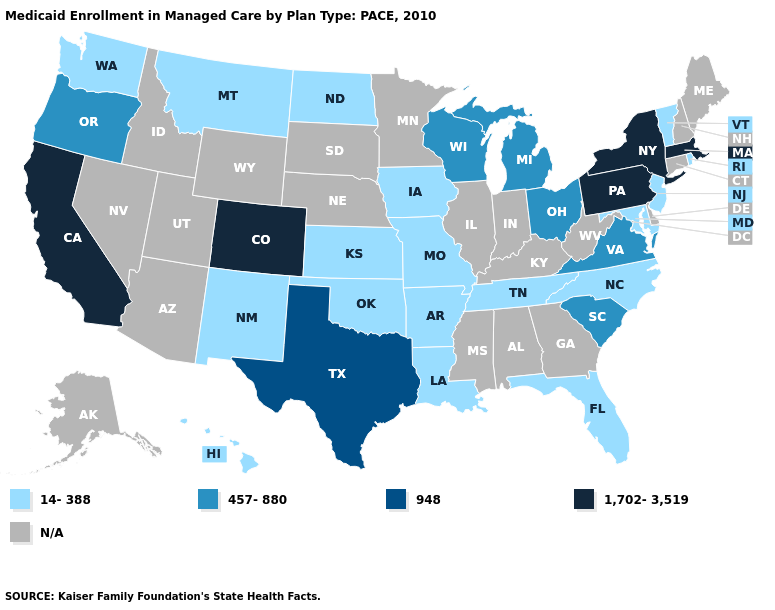Among the states that border Wyoming , which have the highest value?
Quick response, please. Colorado. Name the states that have a value in the range 1,702-3,519?
Short answer required. California, Colorado, Massachusetts, New York, Pennsylvania. Name the states that have a value in the range 14-388?
Keep it brief. Arkansas, Florida, Hawaii, Iowa, Kansas, Louisiana, Maryland, Missouri, Montana, New Jersey, New Mexico, North Carolina, North Dakota, Oklahoma, Rhode Island, Tennessee, Vermont, Washington. Is the legend a continuous bar?
Write a very short answer. No. Which states have the highest value in the USA?
Quick response, please. California, Colorado, Massachusetts, New York, Pennsylvania. Is the legend a continuous bar?
Keep it brief. No. Does Oregon have the highest value in the West?
Give a very brief answer. No. What is the lowest value in the West?
Give a very brief answer. 14-388. Does the first symbol in the legend represent the smallest category?
Write a very short answer. Yes. What is the highest value in the Northeast ?
Keep it brief. 1,702-3,519. Does Kansas have the lowest value in the USA?
Quick response, please. Yes. Name the states that have a value in the range 948?
Give a very brief answer. Texas. Name the states that have a value in the range 1,702-3,519?
Write a very short answer. California, Colorado, Massachusetts, New York, Pennsylvania. What is the highest value in the USA?
Keep it brief. 1,702-3,519. 